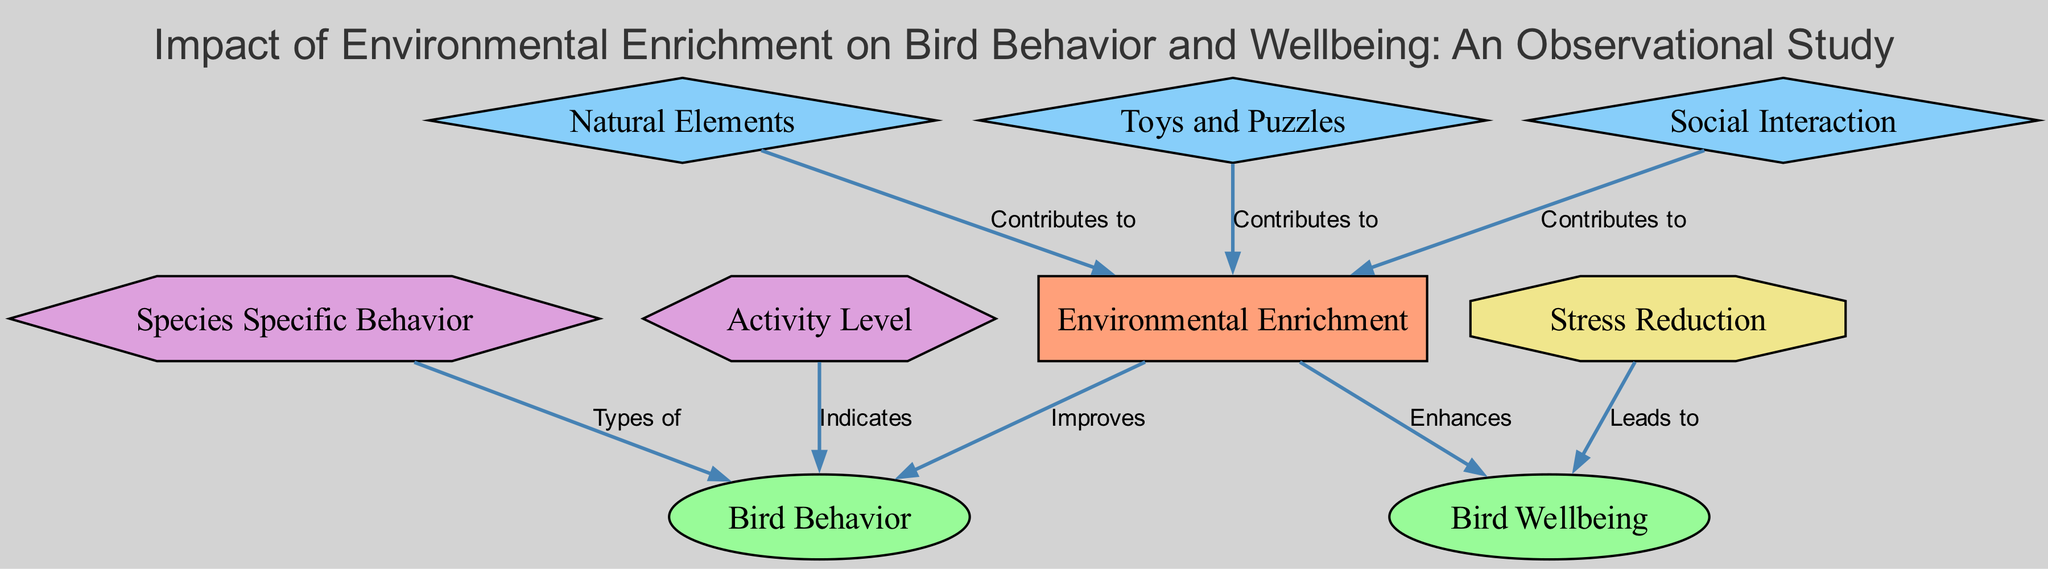What is the title of the diagram? The title is explicitly stated at the top of the diagram. From the provided data, it is "Impact of Environmental Enrichment on Bird Behavior and Wellbeing: An Observational Study".
Answer: Impact of Environmental Enrichment on Bird Behavior and Wellbeing: An Observational Study How many nodes are present in the diagram? The total number of nodes can be counted from the "nodes" section in the provided data, which lists 8 unique nodes.
Answer: 8 What type of node is "Environmental Enrichment"? By examining the "category" field of the node, "Environmental Enrichment" is categorized as an "Intervention".
Answer: Intervention Which edge indicates the direct relationship between environmental enrichment and bird behavior? The edge from "environmental_enrichment" to "bird_behavior" with the label "Improves" directly indicates this relationship.
Answer: Improves What does "Stress Reduction" lead to in terms of wellbeing? The diagram shows that "Stress Reduction" leads to "Wellbeing" as indicated by the directed edge with the label "Leads to".
Answer: Wellbeing What are the three types of enrichment that contribute to environmental enrichment? The diagram includes three nodes labeled "Natural Elements", "Toys and Puzzles", and "Social Interaction", all connected to "Environmental Enrichment".
Answer: Natural Elements, Toys and Puzzles, Social Interaction Which behavior type is indicated by the activity level? The diagram specifies that the "activity level" indicates a type of behavior, represented by the node "bird_behavior".
Answer: bird_behavior Does "Environmental Enrichment" enhance bird wellbeing? Yes, the diagram explicitly states that "Environmental Enrichment" enhances "Wellbeing", as seen from the edge labeled "Enhances".
Answer: Enhances What is the outcome of "Species Specific Behavior"? "Species Specific Behavior" is categorized under behavior, relating to "bird_behavior" which indicates the types of behavior exhibited.
Answer: Types of behavior 